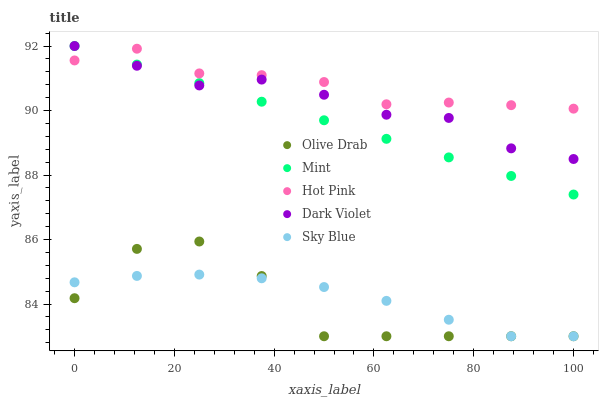Does Olive Drab have the minimum area under the curve?
Answer yes or no. Yes. Does Hot Pink have the maximum area under the curve?
Answer yes or no. Yes. Does Mint have the minimum area under the curve?
Answer yes or no. No. Does Mint have the maximum area under the curve?
Answer yes or no. No. Is Mint the smoothest?
Answer yes or no. Yes. Is Olive Drab the roughest?
Answer yes or no. Yes. Is Hot Pink the smoothest?
Answer yes or no. No. Is Hot Pink the roughest?
Answer yes or no. No. Does Sky Blue have the lowest value?
Answer yes or no. Yes. Does Mint have the lowest value?
Answer yes or no. No. Does Dark Violet have the highest value?
Answer yes or no. Yes. Does Hot Pink have the highest value?
Answer yes or no. No. Is Sky Blue less than Dark Violet?
Answer yes or no. Yes. Is Dark Violet greater than Sky Blue?
Answer yes or no. Yes. Does Sky Blue intersect Olive Drab?
Answer yes or no. Yes. Is Sky Blue less than Olive Drab?
Answer yes or no. No. Is Sky Blue greater than Olive Drab?
Answer yes or no. No. Does Sky Blue intersect Dark Violet?
Answer yes or no. No. 